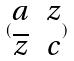<formula> <loc_0><loc_0><loc_500><loc_500>( \begin{matrix} a & z \\ \overline { z } & c \end{matrix} )</formula> 